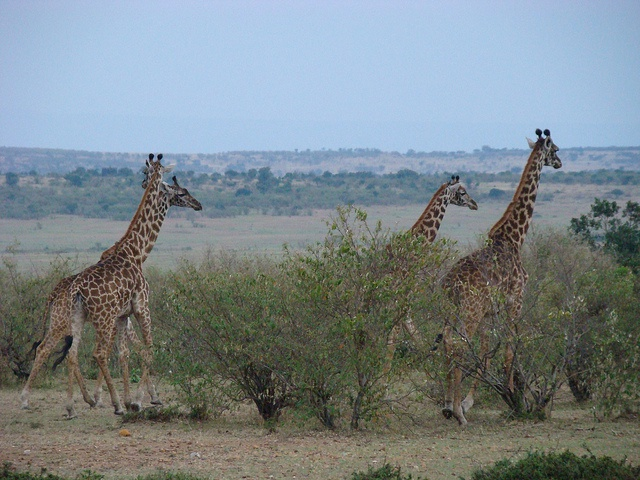Describe the objects in this image and their specific colors. I can see giraffe in lightblue, gray, and black tones, giraffe in lightblue, gray, maroon, and black tones, giraffe in lightblue, gray, darkgreen, and black tones, and giraffe in lightblue, gray, and maroon tones in this image. 